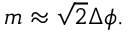Convert formula to latex. <formula><loc_0><loc_0><loc_500><loc_500>m \approx { \sqrt { 2 } } \Delta \phi .</formula> 